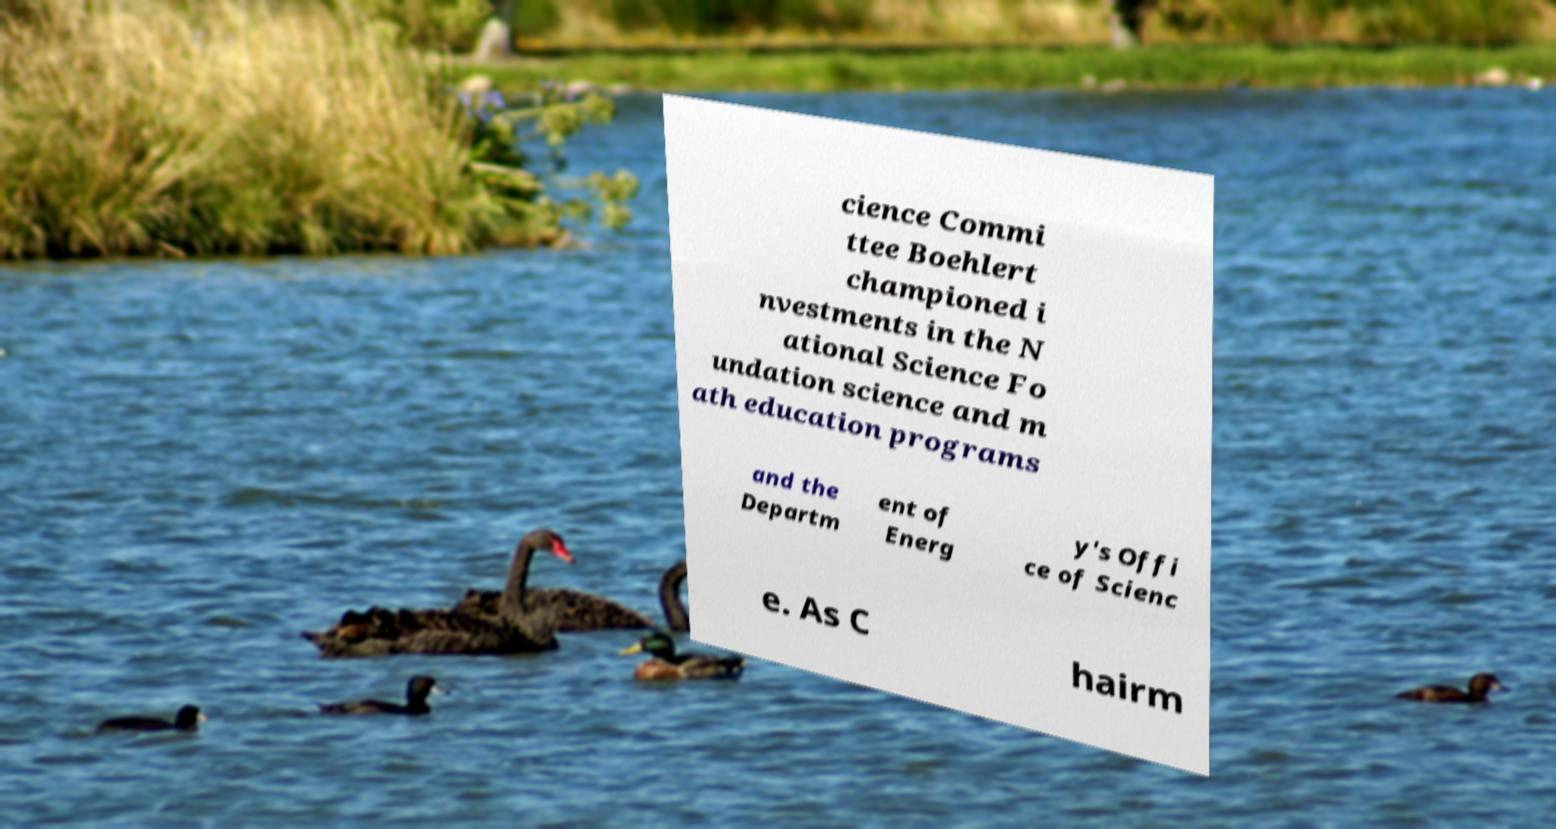Please identify and transcribe the text found in this image. cience Commi ttee Boehlert championed i nvestments in the N ational Science Fo undation science and m ath education programs and the Departm ent of Energ y's Offi ce of Scienc e. As C hairm 